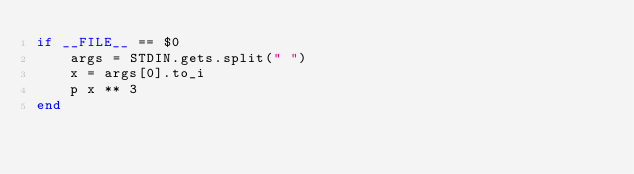Convert code to text. <code><loc_0><loc_0><loc_500><loc_500><_Ruby_>if __FILE__ == $0 
	args = STDIN.gets.split(" ")
	x = args[0].to_i
	p x ** 3
end</code> 